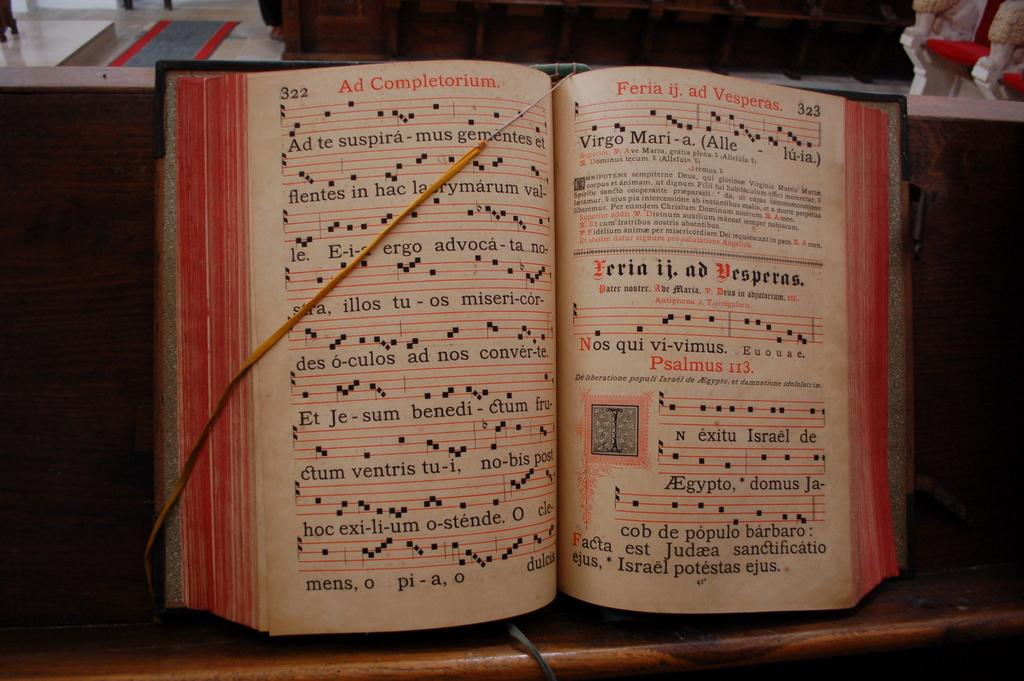<image>
Summarize the visual content of the image. Pages 322 and 323 are being held open by a string for the musician. 